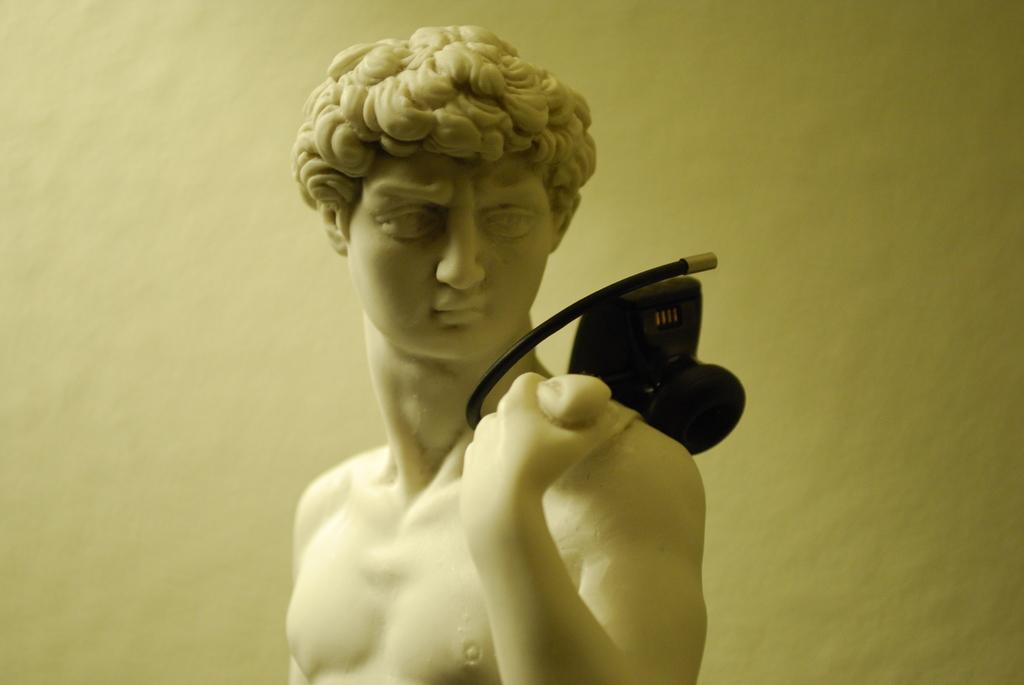What is the main subject of the image? There is a stone carved statue of a man in the image. Can you describe the object behind the statue? There is an object in black color behind the statue. What can be seen in the background of the image? There is a wall in the background of the image, and it is white in color. What type of trousers is the statue wearing in the image? The statue is made of stone and does not have clothing, so it is not wearing any trousers. How many knots can be seen in the image? There are no knots visible in the image. 